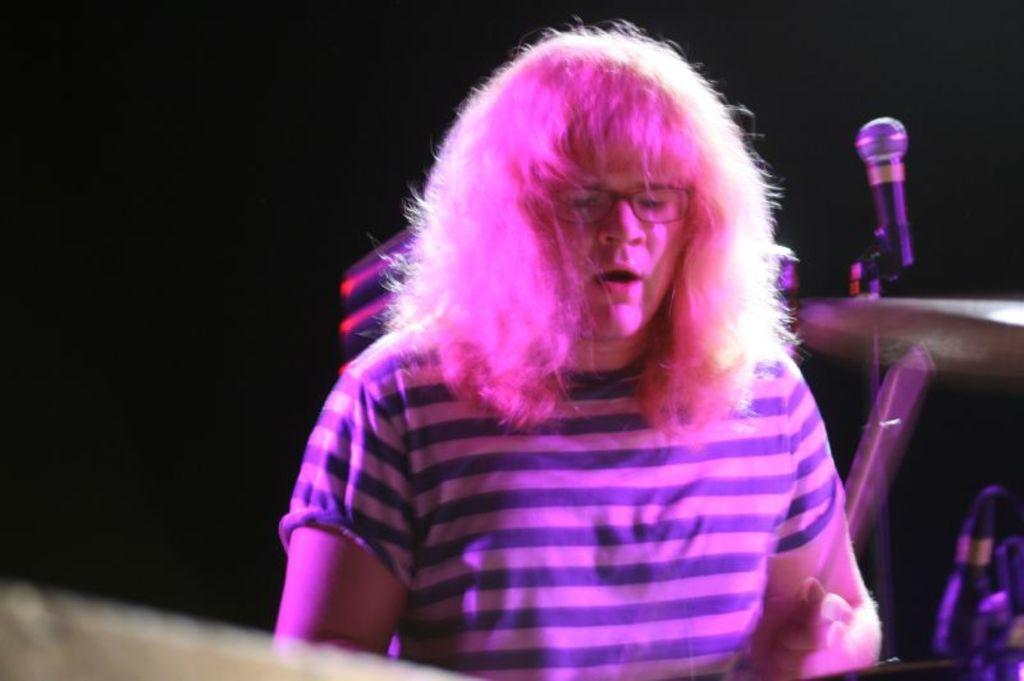What can be seen in the image? There is a person in the image. What is the person wearing? The person is wearing a t-shirt. What object is present in the image that is typically used for amplifying sound? There is a microphone in the image. How would you describe the background of the image? The background of the image is dark. Can you describe any other objects or elements in the image? There are additional objects or elements in the image, but their specific details are not mentioned in the provided facts. What type of canvas is the person painting in the image? There is no canvas present in the image, nor is there any indication that the person is painting. 